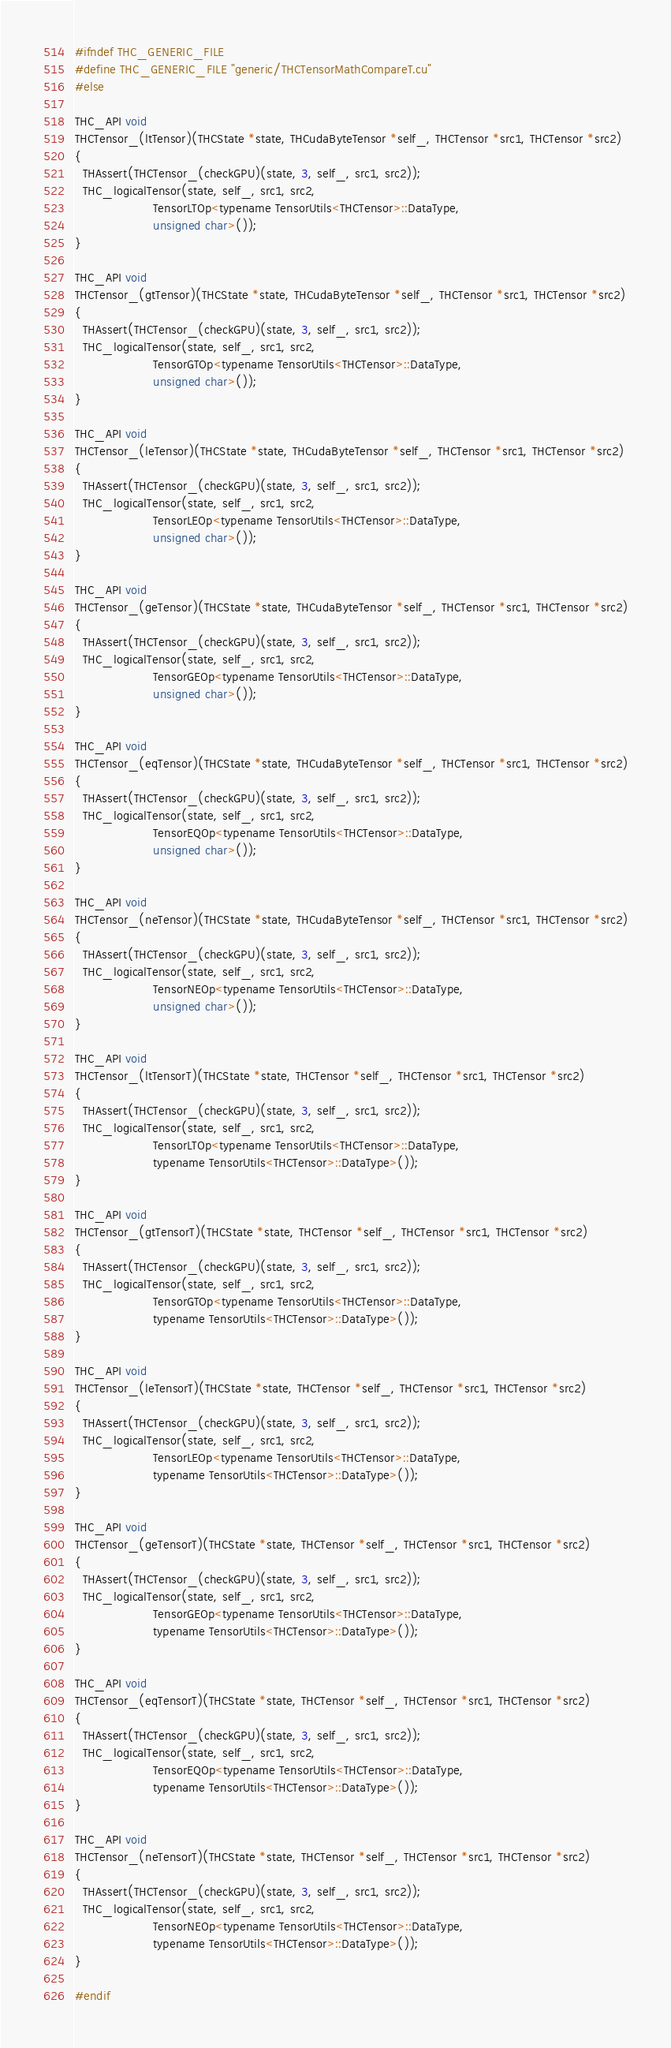Convert code to text. <code><loc_0><loc_0><loc_500><loc_500><_Cuda_>#ifndef THC_GENERIC_FILE
#define THC_GENERIC_FILE "generic/THCTensorMathCompareT.cu"
#else

THC_API void
THCTensor_(ltTensor)(THCState *state, THCudaByteTensor *self_, THCTensor *src1, THCTensor *src2)
{
  THAssert(THCTensor_(checkGPU)(state, 3, self_, src1, src2));
  THC_logicalTensor(state, self_, src1, src2,
                    TensorLTOp<typename TensorUtils<THCTensor>::DataType,
                    unsigned char>());
}

THC_API void
THCTensor_(gtTensor)(THCState *state, THCudaByteTensor *self_, THCTensor *src1, THCTensor *src2)
{
  THAssert(THCTensor_(checkGPU)(state, 3, self_, src1, src2));
  THC_logicalTensor(state, self_, src1, src2,
                    TensorGTOp<typename TensorUtils<THCTensor>::DataType,
                    unsigned char>());
}

THC_API void
THCTensor_(leTensor)(THCState *state, THCudaByteTensor *self_, THCTensor *src1, THCTensor *src2)
{
  THAssert(THCTensor_(checkGPU)(state, 3, self_, src1, src2));
  THC_logicalTensor(state, self_, src1, src2,
                    TensorLEOp<typename TensorUtils<THCTensor>::DataType,
                    unsigned char>());
}

THC_API void
THCTensor_(geTensor)(THCState *state, THCudaByteTensor *self_, THCTensor *src1, THCTensor *src2)
{
  THAssert(THCTensor_(checkGPU)(state, 3, self_, src1, src2));
  THC_logicalTensor(state, self_, src1, src2,
                    TensorGEOp<typename TensorUtils<THCTensor>::DataType,
                    unsigned char>());
}

THC_API void
THCTensor_(eqTensor)(THCState *state, THCudaByteTensor *self_, THCTensor *src1, THCTensor *src2)
{
  THAssert(THCTensor_(checkGPU)(state, 3, self_, src1, src2));
  THC_logicalTensor(state, self_, src1, src2,
                    TensorEQOp<typename TensorUtils<THCTensor>::DataType,
                    unsigned char>());
}

THC_API void
THCTensor_(neTensor)(THCState *state, THCudaByteTensor *self_, THCTensor *src1, THCTensor *src2)
{
  THAssert(THCTensor_(checkGPU)(state, 3, self_, src1, src2));
  THC_logicalTensor(state, self_, src1, src2,
                    TensorNEOp<typename TensorUtils<THCTensor>::DataType,
                    unsigned char>());
}

THC_API void
THCTensor_(ltTensorT)(THCState *state, THCTensor *self_, THCTensor *src1, THCTensor *src2)
{
  THAssert(THCTensor_(checkGPU)(state, 3, self_, src1, src2));
  THC_logicalTensor(state, self_, src1, src2,
                    TensorLTOp<typename TensorUtils<THCTensor>::DataType,
                    typename TensorUtils<THCTensor>::DataType>());
}

THC_API void
THCTensor_(gtTensorT)(THCState *state, THCTensor *self_, THCTensor *src1, THCTensor *src2)
{
  THAssert(THCTensor_(checkGPU)(state, 3, self_, src1, src2));
  THC_logicalTensor(state, self_, src1, src2,
                    TensorGTOp<typename TensorUtils<THCTensor>::DataType,
                    typename TensorUtils<THCTensor>::DataType>());
}

THC_API void
THCTensor_(leTensorT)(THCState *state, THCTensor *self_, THCTensor *src1, THCTensor *src2)
{
  THAssert(THCTensor_(checkGPU)(state, 3, self_, src1, src2));
  THC_logicalTensor(state, self_, src1, src2,
                    TensorLEOp<typename TensorUtils<THCTensor>::DataType,
                    typename TensorUtils<THCTensor>::DataType>());
}

THC_API void
THCTensor_(geTensorT)(THCState *state, THCTensor *self_, THCTensor *src1, THCTensor *src2)
{
  THAssert(THCTensor_(checkGPU)(state, 3, self_, src1, src2));
  THC_logicalTensor(state, self_, src1, src2,
                    TensorGEOp<typename TensorUtils<THCTensor>::DataType,
                    typename TensorUtils<THCTensor>::DataType>());
}

THC_API void
THCTensor_(eqTensorT)(THCState *state, THCTensor *self_, THCTensor *src1, THCTensor *src2)
{
  THAssert(THCTensor_(checkGPU)(state, 3, self_, src1, src2));
  THC_logicalTensor(state, self_, src1, src2,
                    TensorEQOp<typename TensorUtils<THCTensor>::DataType,
                    typename TensorUtils<THCTensor>::DataType>());
}

THC_API void
THCTensor_(neTensorT)(THCState *state, THCTensor *self_, THCTensor *src1, THCTensor *src2)
{
  THAssert(THCTensor_(checkGPU)(state, 3, self_, src1, src2));
  THC_logicalTensor(state, self_, src1, src2,
                    TensorNEOp<typename TensorUtils<THCTensor>::DataType,
                    typename TensorUtils<THCTensor>::DataType>());
}

#endif
</code> 